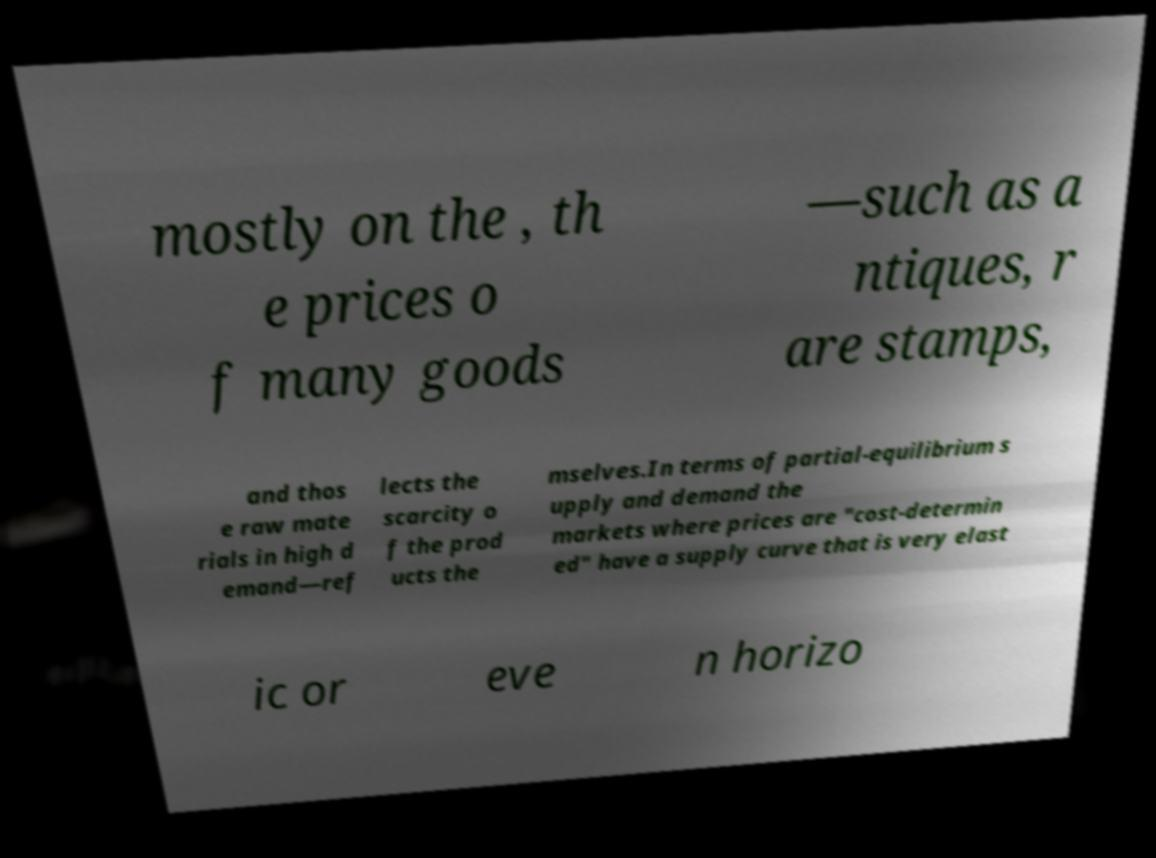Please read and relay the text visible in this image. What does it say? mostly on the , th e prices o f many goods —such as a ntiques, r are stamps, and thos e raw mate rials in high d emand—ref lects the scarcity o f the prod ucts the mselves.In terms of partial-equilibrium s upply and demand the markets where prices are "cost-determin ed" have a supply curve that is very elast ic or eve n horizo 